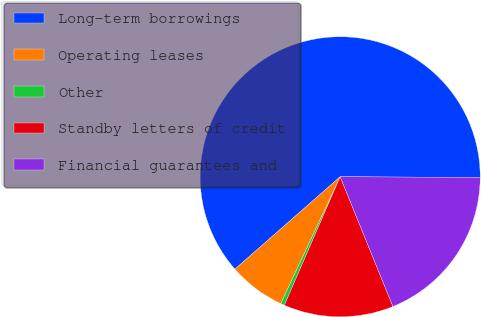<chart> <loc_0><loc_0><loc_500><loc_500><pie_chart><fcel>Long-term borrowings<fcel>Operating leases<fcel>Other<fcel>Standby letters of credit<fcel>Financial guarantees and<nl><fcel>61.54%<fcel>6.56%<fcel>0.45%<fcel>12.67%<fcel>18.78%<nl></chart> 